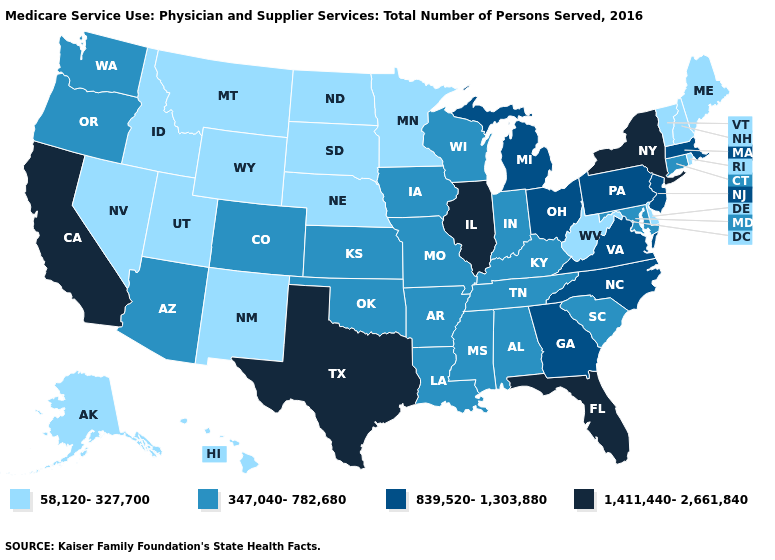Name the states that have a value in the range 839,520-1,303,880?
Keep it brief. Georgia, Massachusetts, Michigan, New Jersey, North Carolina, Ohio, Pennsylvania, Virginia. What is the value of Alabama?
Give a very brief answer. 347,040-782,680. Which states have the highest value in the USA?
Be succinct. California, Florida, Illinois, New York, Texas. Name the states that have a value in the range 58,120-327,700?
Write a very short answer. Alaska, Delaware, Hawaii, Idaho, Maine, Minnesota, Montana, Nebraska, Nevada, New Hampshire, New Mexico, North Dakota, Rhode Island, South Dakota, Utah, Vermont, West Virginia, Wyoming. Does South Carolina have the highest value in the South?
Write a very short answer. No. Name the states that have a value in the range 1,411,440-2,661,840?
Short answer required. California, Florida, Illinois, New York, Texas. What is the value of Nevada?
Concise answer only. 58,120-327,700. What is the value of Maryland?
Give a very brief answer. 347,040-782,680. What is the value of Wisconsin?
Keep it brief. 347,040-782,680. Does Kentucky have the lowest value in the USA?
Be succinct. No. Which states hav the highest value in the MidWest?
Concise answer only. Illinois. How many symbols are there in the legend?
Quick response, please. 4. Among the states that border Nebraska , does Iowa have the highest value?
Short answer required. Yes. What is the lowest value in states that border South Dakota?
Be succinct. 58,120-327,700. Among the states that border Oklahoma , does New Mexico have the lowest value?
Be succinct. Yes. 